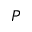Convert formula to latex. <formula><loc_0><loc_0><loc_500><loc_500>P</formula> 